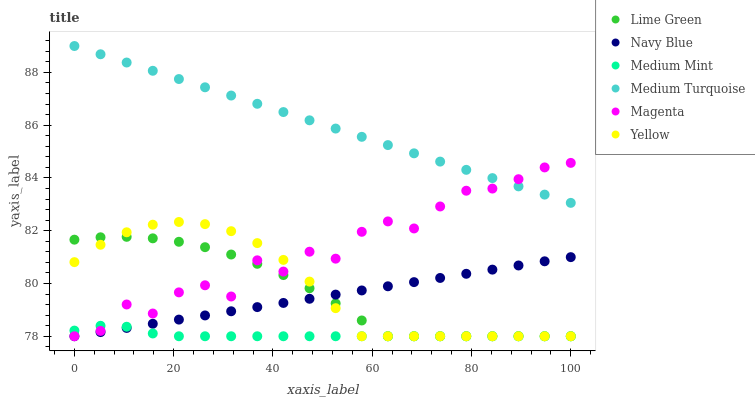Does Medium Mint have the minimum area under the curve?
Answer yes or no. Yes. Does Medium Turquoise have the maximum area under the curve?
Answer yes or no. Yes. Does Navy Blue have the minimum area under the curve?
Answer yes or no. No. Does Navy Blue have the maximum area under the curve?
Answer yes or no. No. Is Medium Turquoise the smoothest?
Answer yes or no. Yes. Is Magenta the roughest?
Answer yes or no. Yes. Is Navy Blue the smoothest?
Answer yes or no. No. Is Navy Blue the roughest?
Answer yes or no. No. Does Medium Mint have the lowest value?
Answer yes or no. Yes. Does Medium Turquoise have the lowest value?
Answer yes or no. No. Does Medium Turquoise have the highest value?
Answer yes or no. Yes. Does Navy Blue have the highest value?
Answer yes or no. No. Is Medium Mint less than Medium Turquoise?
Answer yes or no. Yes. Is Medium Turquoise greater than Yellow?
Answer yes or no. Yes. Does Medium Mint intersect Yellow?
Answer yes or no. Yes. Is Medium Mint less than Yellow?
Answer yes or no. No. Is Medium Mint greater than Yellow?
Answer yes or no. No. Does Medium Mint intersect Medium Turquoise?
Answer yes or no. No. 